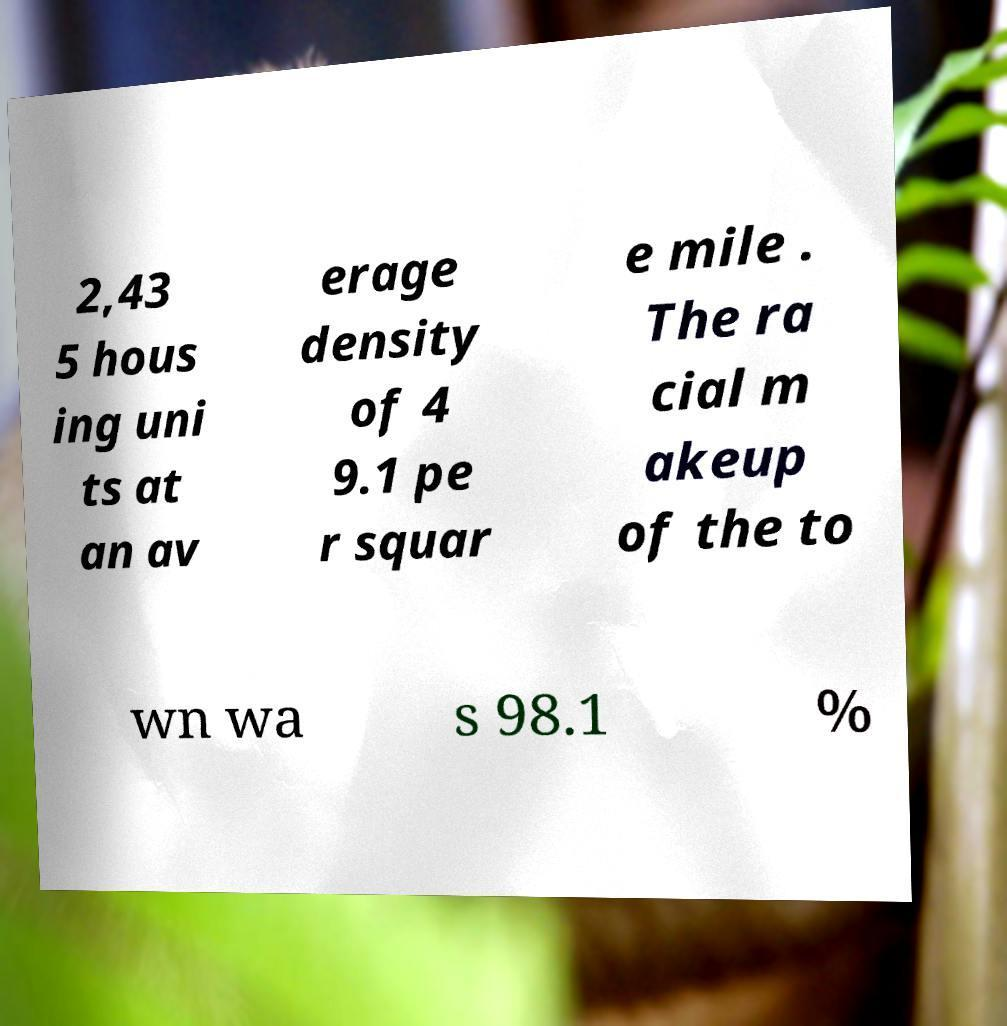What messages or text are displayed in this image? I need them in a readable, typed format. 2,43 5 hous ing uni ts at an av erage density of 4 9.1 pe r squar e mile . The ra cial m akeup of the to wn wa s 98.1 % 